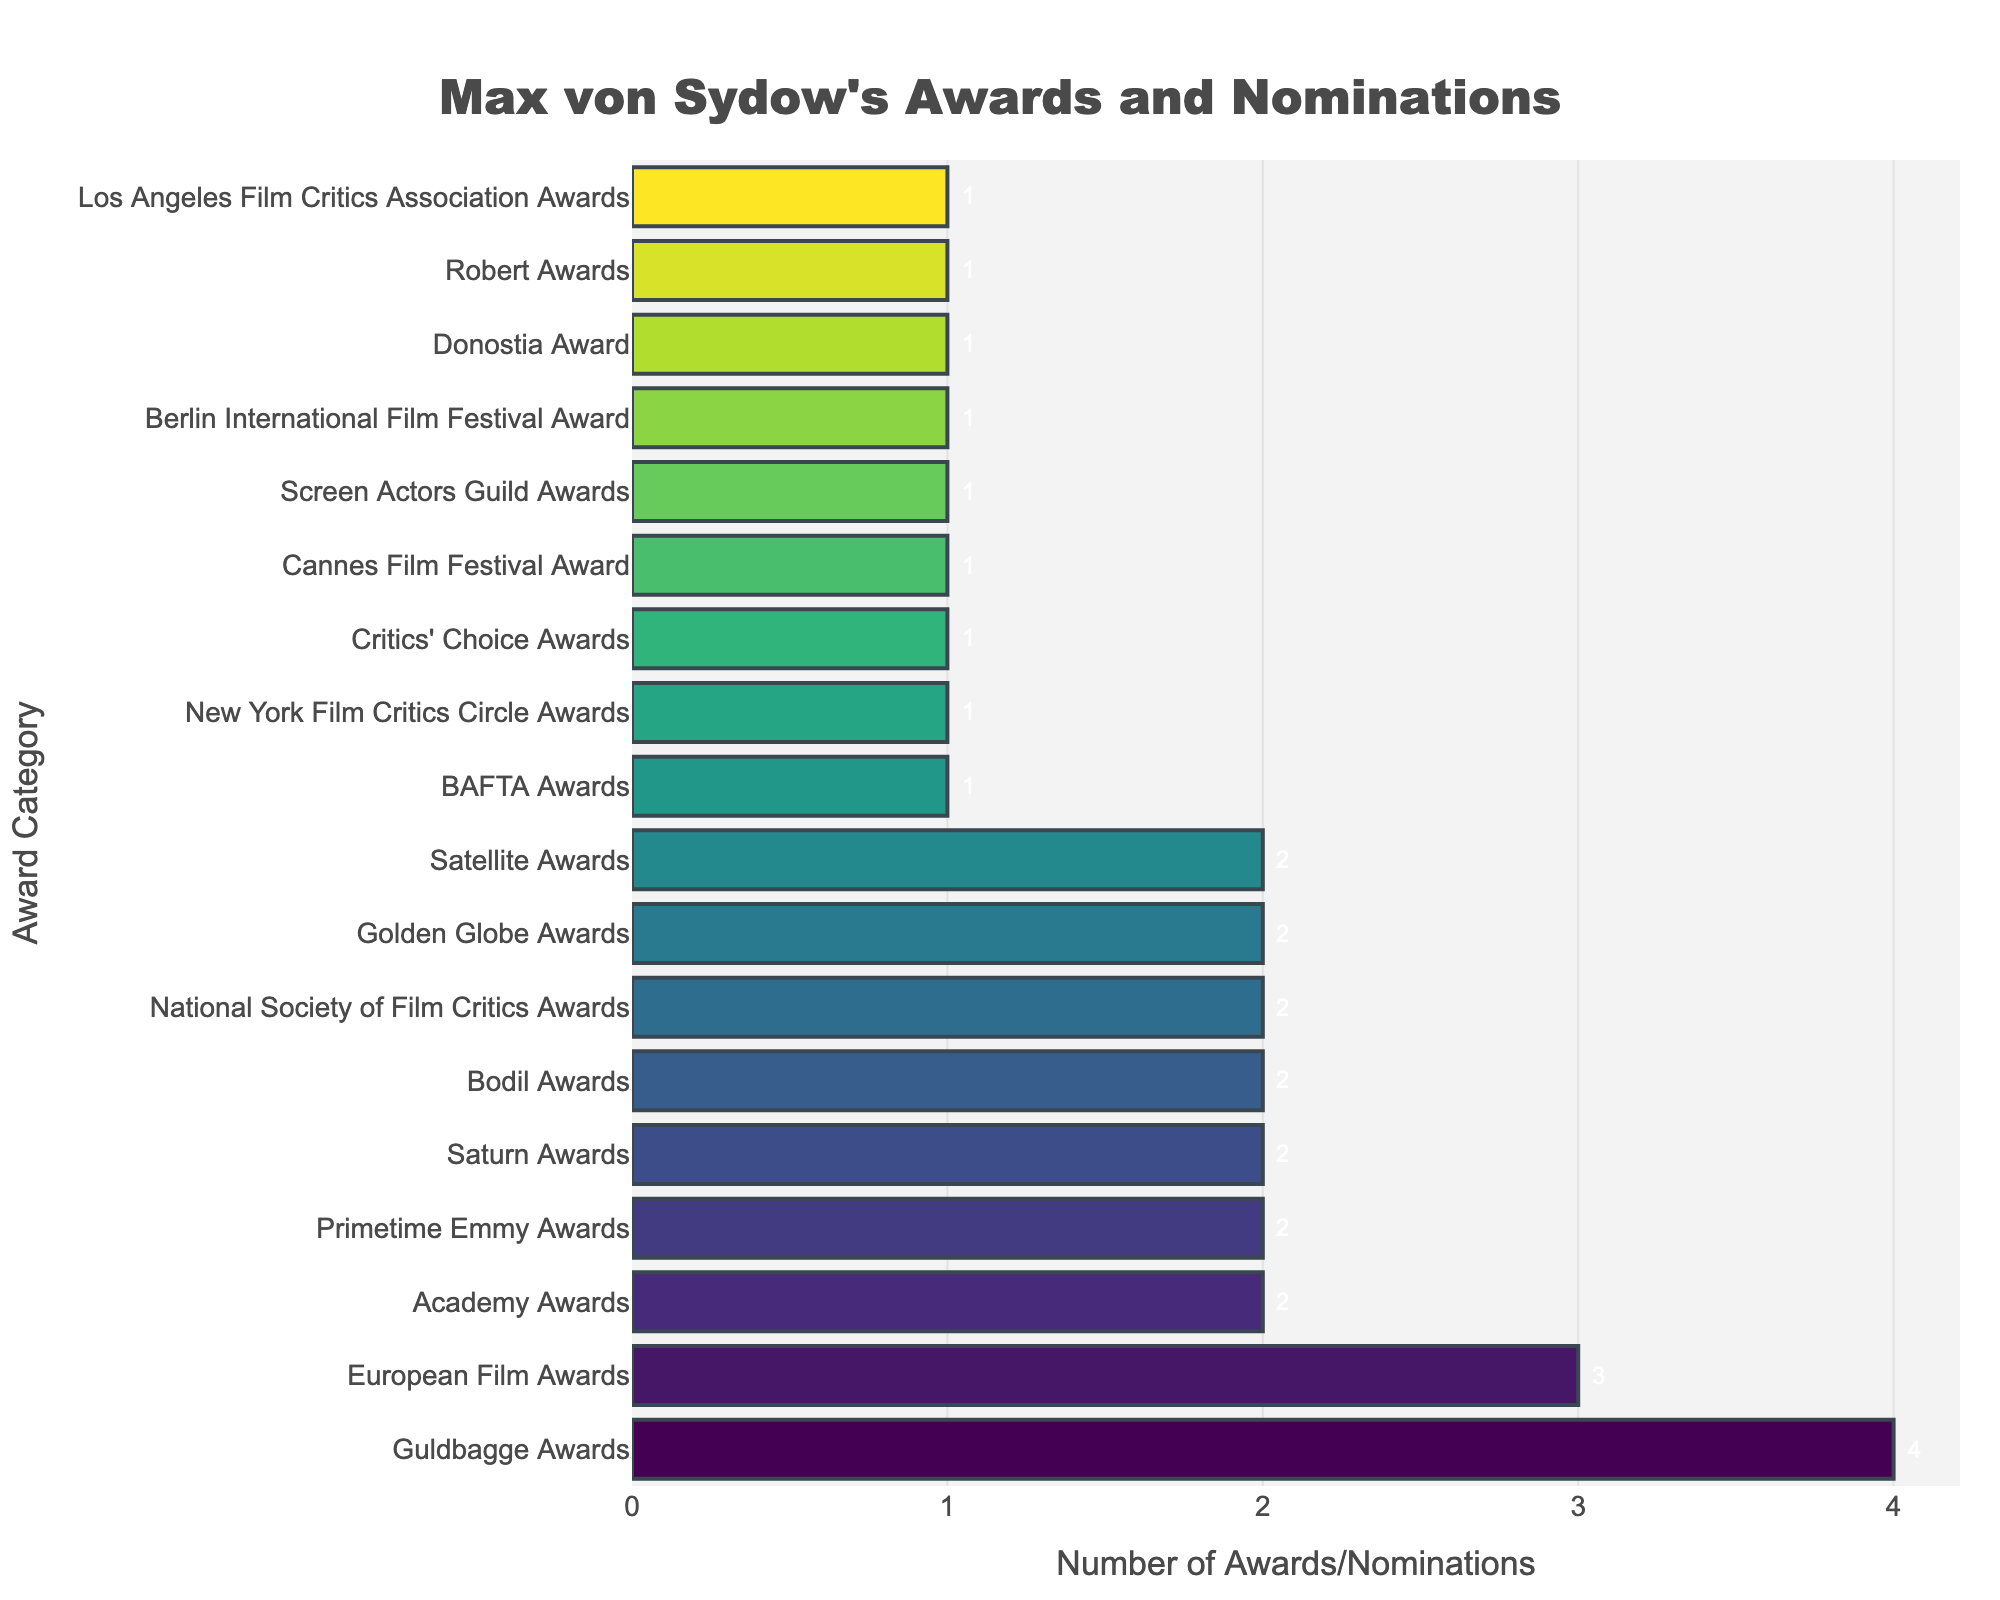Which award category has the highest number of awards/nominations received by Max von Sydow? Max von Sydow received the highest number of awards/nominations in the "Guldbagge Awards" category, with a total of 4.
Answer: Guldbagge Awards What is the total number of awards/nominations received by Max von Sydow across all categories? Adding all the numbers in the "Number of Awards/Nominations" column: 2 + 2 + 2 + 3 + 4 + 2 + 2 + 1 + 1 + 1 + 1 + 2 + 1 + 1 + 1 + 2 + 1 + 1 = 30.
Answer: 30 How many categories have exactly 2 awards/nominations received by Max von Sydow? Count the number of categories where "Number of Awards/Nominations" is 2. The categories are Academy Awards, Golden Globe Awards, Primetime Emmy Awards, Saturn Awards, Bodil Awards, and Satellite Awards. There are 6 such categories.
Answer: 6 Which two categories have the same number of awards/nominations as the "Prime Time Emmy Awards" category? The "Primetime Emmy Awards" category has 2 awards/nominations. Categories with the same number are Academy Awards, Golden Globe Awards, Saturn Awards, Bodil Awards, and Satellite Awards. Choose two of these: such as Academy Awards and Golden Globe Awards.
Answer: Academy Awards, Golden Globe Awards What is the difference between the number of awards/nominations in the European Film Awards category and the BAFTA Awards category? The European Film Awards category has 3 awards/nominations, and the BAFTA Awards category has 1. The difference is 3 - 1 = 2.
Answer: 2 Which categories have only received 1 award/nomination? Categories with only 1 award/nomination are Robert Awards, Donostia Award, Cannes Film Festival Award, Berlin International Film Festival Award, Screen Actors Guild Awards, BAFTA Awards, New York Film Critics Circle Awards, and Los Angeles Film Critics Association Awards.
Answer: Robert Awards, Donostia Award, Cannes Film Festival Award, Berlin International Film Festival Award, Screen Actors Guild Awards, BAFTA Awards, New York Film Critics Circle Awards, Los Angeles Film Critics Association Awards What is the sum of the number of awards/nominations in the categories that start with 'C'? Categories starting with 'C' are Cannes Film Festival Award, Critics' Choice Awards. They have 1 and 1 awards/nominations respectively. The sum is 1 + 1 = 2.
Answer: 2 Which award category lies in the middle when the categories are sorted by numbers of awards/nominations in descending order? The sorted list in descending order by number of awards/nominations is: Guldbagge Awards, European Film Awards, Academy Awards, Golden Globe Awards, Primetime Emmy Awards, Saturn Awards, Bodil Awards, National Society of Film Critics Awards, Satellite Awards, Robert Awards, Donostia Award, Cannes Film Festival Award, Berlin International Film Festival Award, Screen Actors Guild Awards, BAFTA Awards, Critics' Choice Awards, New York Film Critics Circle Awards, Los Angeles Film Critics Association Awards. The middle (9th) category is National Society of Film Critics Awards.
Answer: National Society of Film Critics Awards Is the number of awards/nominations for the Academy Awards category greater than that of the Berlin International Film Festival Award category? The Academy Awards category has 2 awards/nominations while the Berlin International Film Festival Award category has 1 award/nomination. So, 2 is greater than 1.
Answer: Yes 